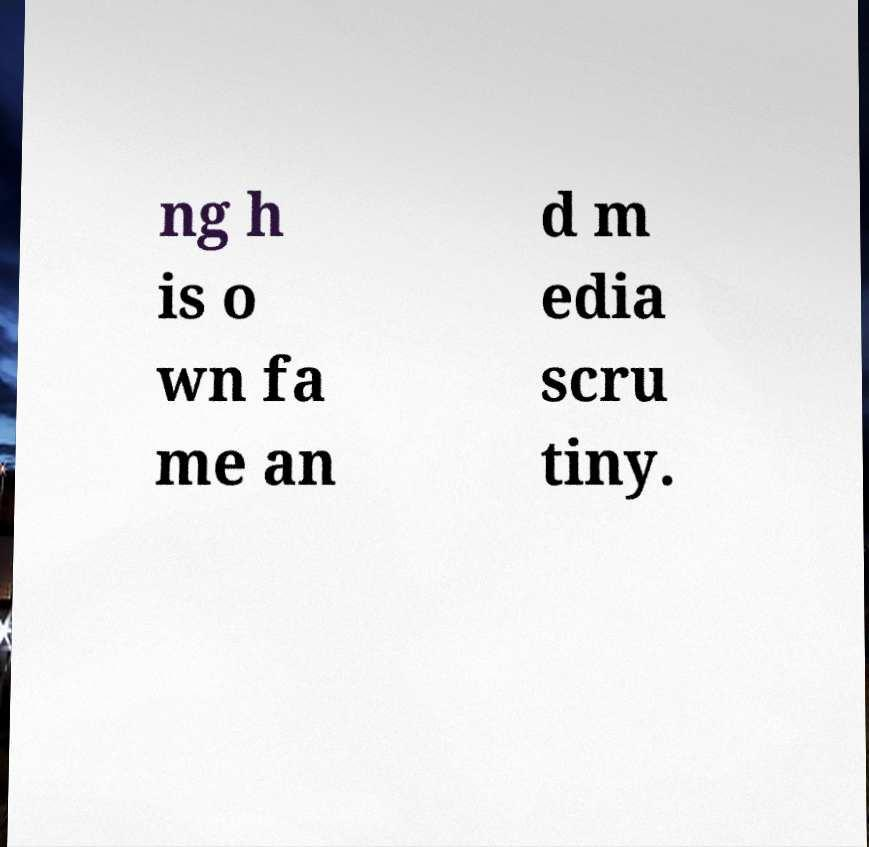Can you read and provide the text displayed in the image?This photo seems to have some interesting text. Can you extract and type it out for me? ng h is o wn fa me an d m edia scru tiny. 